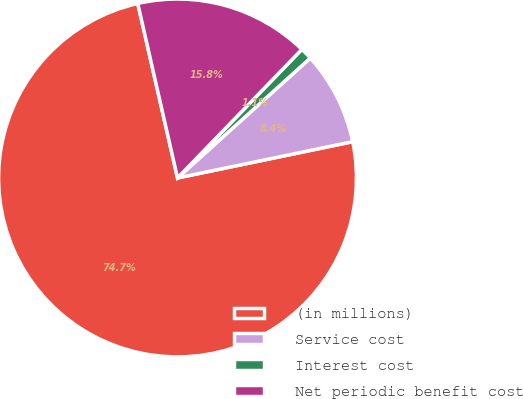<chart> <loc_0><loc_0><loc_500><loc_500><pie_chart><fcel>(in millions)<fcel>Service cost<fcel>Interest cost<fcel>Net periodic benefit cost<nl><fcel>74.69%<fcel>8.44%<fcel>1.08%<fcel>15.8%<nl></chart> 